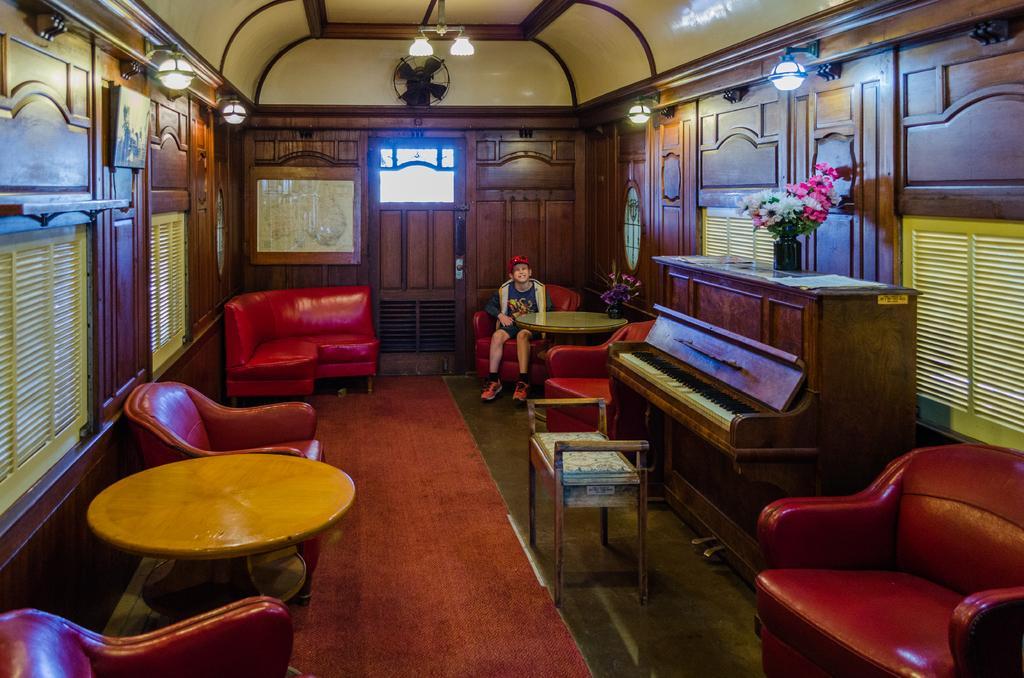Please provide a concise description of this image. The image is inside the room. In the image on right side we can see a couch,musical keyboard,flower pot,table and a boy sitting on couch. On left side we can see windows,photo frame, in middle there is a door which is closed. On top we can see a fan,roof with few lights. 